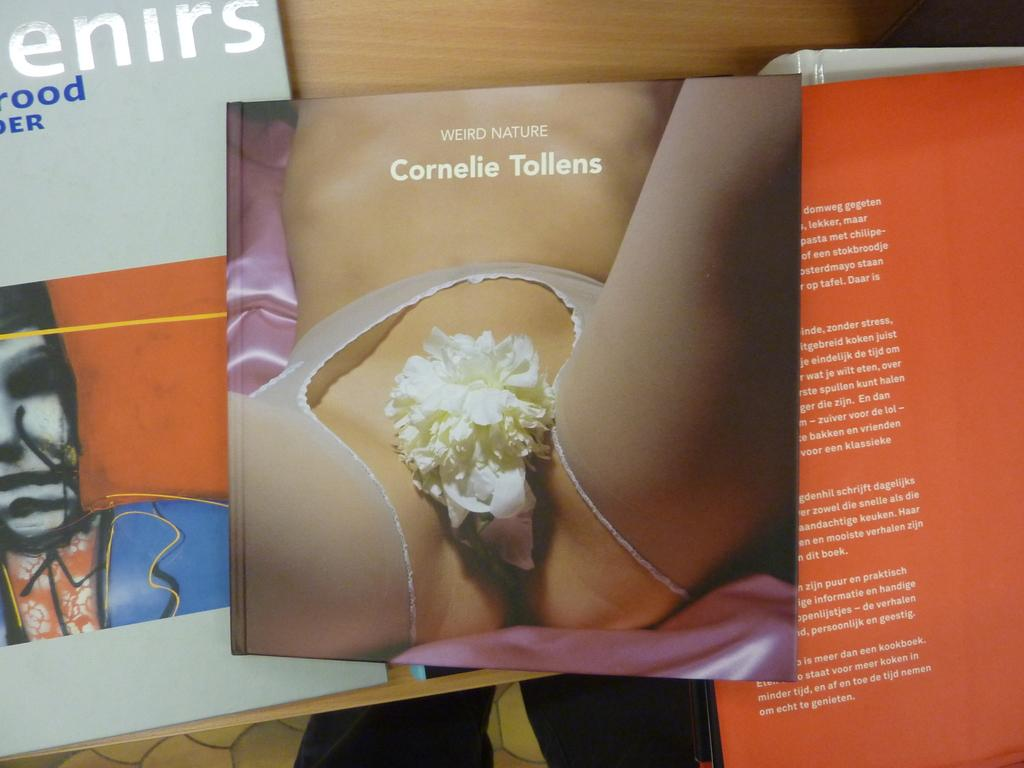<image>
Create a compact narrative representing the image presented. For some reason, a woman has a flower over her privates while the text is about weird nature. 